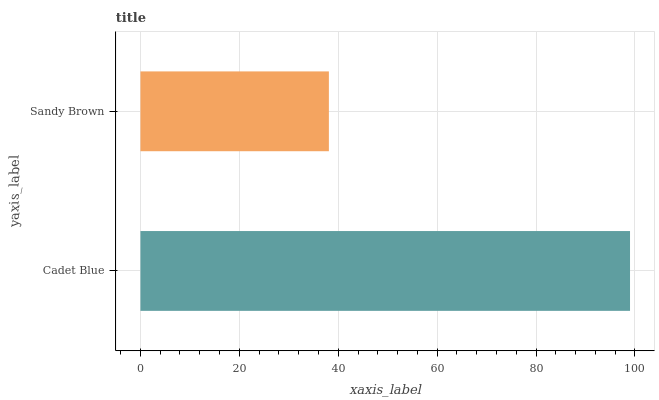Is Sandy Brown the minimum?
Answer yes or no. Yes. Is Cadet Blue the maximum?
Answer yes or no. Yes. Is Sandy Brown the maximum?
Answer yes or no. No. Is Cadet Blue greater than Sandy Brown?
Answer yes or no. Yes. Is Sandy Brown less than Cadet Blue?
Answer yes or no. Yes. Is Sandy Brown greater than Cadet Blue?
Answer yes or no. No. Is Cadet Blue less than Sandy Brown?
Answer yes or no. No. Is Cadet Blue the high median?
Answer yes or no. Yes. Is Sandy Brown the low median?
Answer yes or no. Yes. Is Sandy Brown the high median?
Answer yes or no. No. Is Cadet Blue the low median?
Answer yes or no. No. 